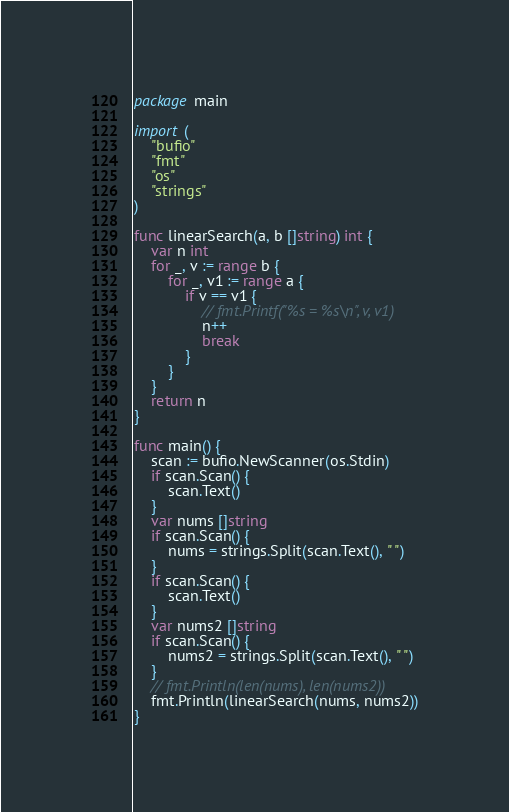<code> <loc_0><loc_0><loc_500><loc_500><_Go_>package main

import (
	"bufio"
	"fmt"
	"os"
	"strings"
)

func linearSearch(a, b []string) int {
	var n int
	for _, v := range b {
		for _, v1 := range a {
			if v == v1 {
				// fmt.Printf("%s = %s\n", v, v1)
				n++
				break
			}
		}
	}
	return n
}

func main() {
	scan := bufio.NewScanner(os.Stdin)
	if scan.Scan() {
		scan.Text()
	}
	var nums []string
	if scan.Scan() {
		nums = strings.Split(scan.Text(), " ")
	}
	if scan.Scan() {
		scan.Text()
	}
	var nums2 []string
	if scan.Scan() {
		nums2 = strings.Split(scan.Text(), " ")
	}
	// fmt.Println(len(nums), len(nums2))
	fmt.Println(linearSearch(nums, nums2))
}

</code> 